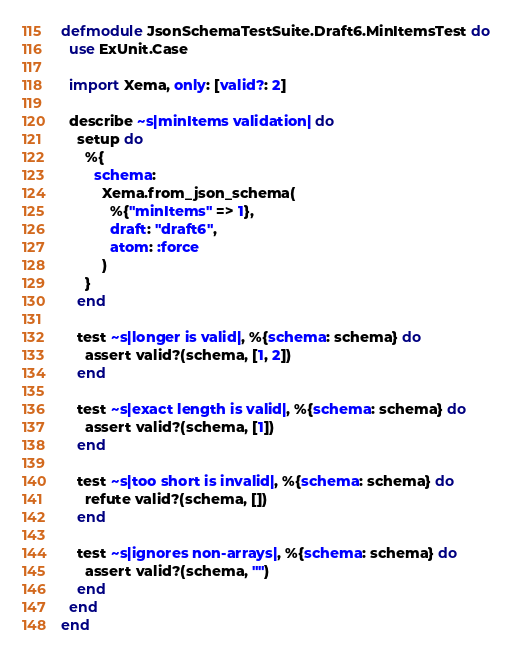Convert code to text. <code><loc_0><loc_0><loc_500><loc_500><_Elixir_>defmodule JsonSchemaTestSuite.Draft6.MinItemsTest do
  use ExUnit.Case

  import Xema, only: [valid?: 2]

  describe ~s|minItems validation| do
    setup do
      %{
        schema:
          Xema.from_json_schema(
            %{"minItems" => 1},
            draft: "draft6",
            atom: :force
          )
      }
    end

    test ~s|longer is valid|, %{schema: schema} do
      assert valid?(schema, [1, 2])
    end

    test ~s|exact length is valid|, %{schema: schema} do
      assert valid?(schema, [1])
    end

    test ~s|too short is invalid|, %{schema: schema} do
      refute valid?(schema, [])
    end

    test ~s|ignores non-arrays|, %{schema: schema} do
      assert valid?(schema, "")
    end
  end
end
</code> 